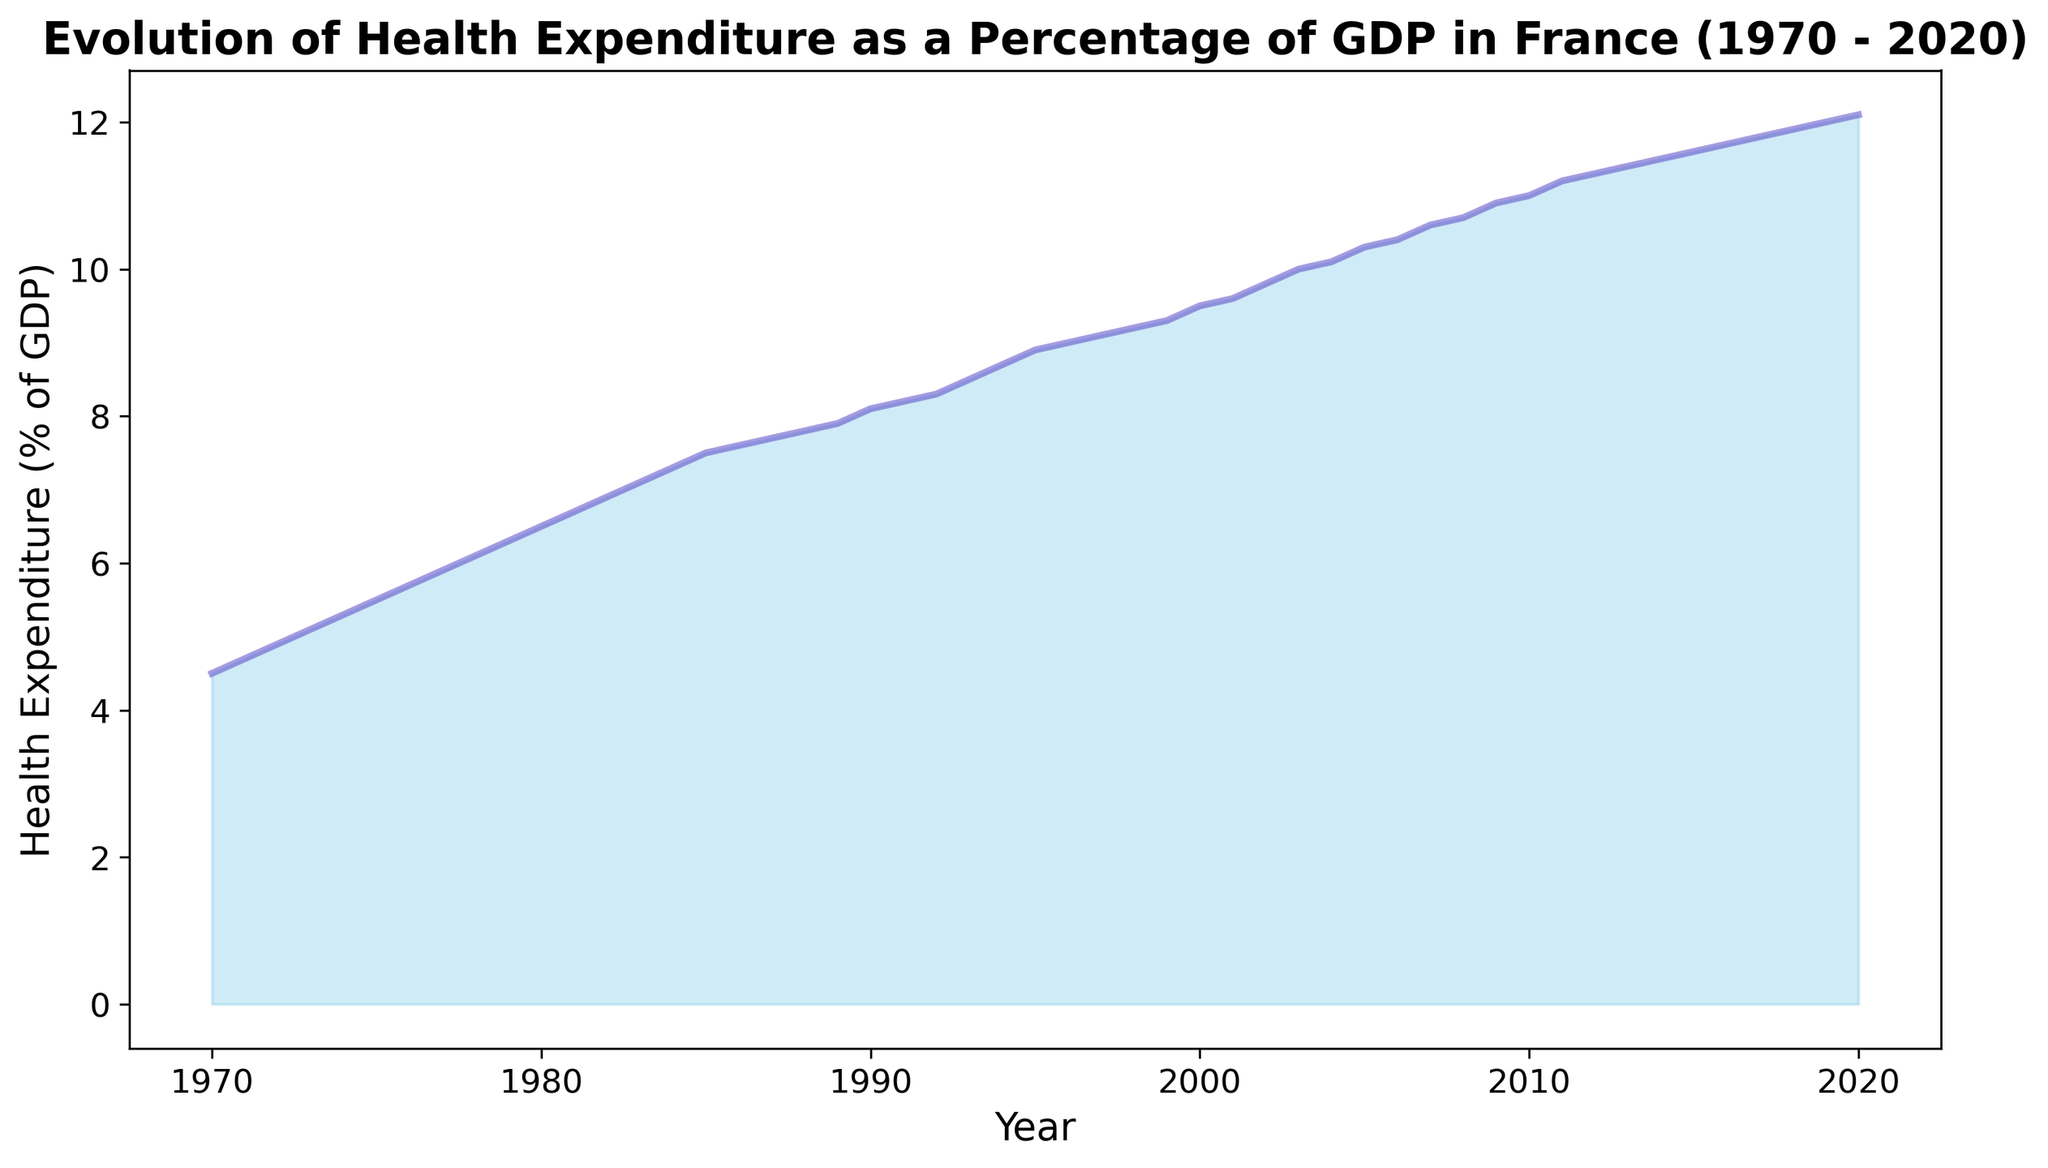What is the general trend in health expenditure as a percentage of GDP from 1970 to 2020 in France? The area chart shows a clear upward trend in health expenditure as a percentage of GDP over the years from 1970 to 2020. The fill color under the line generally increases in height, which indicates that health expenditure as a percentage of GDP has been growing steadily.
Answer: Upward trend During which year did health expenditure as a percentage of GDP reach 10% for the first time? By observing the chart, we can see where the line that represents health expenditure crosses the 10% mark. This occurs in the year 2003.
Answer: 2003 What is the difference in health expenditure percentage of GDP between 1980 and 2020? From the area chart, the health expenditure as a percentage of GDP in 1980 is 6.5%, and in 2020 it is 12.1%. Subtracting these gives 12.1% - 6.5% = 5.6%.
Answer: 5.6% How much did the health expenditure as a percentage of GDP increase from 1990 to 2000? In 1990, the health expenditure percentage is 8.1%, and in 2000, it is 9.5%. The increase is calculated as 9.5% - 8.1% = 1.4%.
Answer: 1.4% During which decade did the health expenditure as a percentage of GDP increase the fastest? By closely examining the slope of the line in the area chart, the steepest slope is visible during the decade from 1970 to 1980. The percentage increased from 4.5% to 6.5%, indicating the fastest rate of increase.
Answer: 1970s What is the average health expenditure as a percentage of GDP over the 50-year period from 1970 to 2020? To find the average over this period, we sum all the percentages from 1970 to 2020 and then divide by the number of years. (4.5 + 4.7 + 4.9 + ... + 12.1) / 51 = 8.37%.
Answer: 8.37% Compare the health expenditure percentage of GDP in 1985 and 1995, which year had higher expenditure? Observing the chart, in 1985, the expenditure was 7.5%, and in 1995, it was 8.9%. 1995 had higher health expenditure as a percentage of GDP compared to 1985.
Answer: 1995 Is there any period where the health expenditure as a percentage of GDP decreased? By looking at the area chart, there are no visible periods where the expenditure decreased; it either increased or remained relatively constant.
Answer: No What color represents the fill of the area in the chart? The fill color of the area chart is a light, translucent sky blue. This is evident from the filled region under the line plot.
Answer: Sky blue 